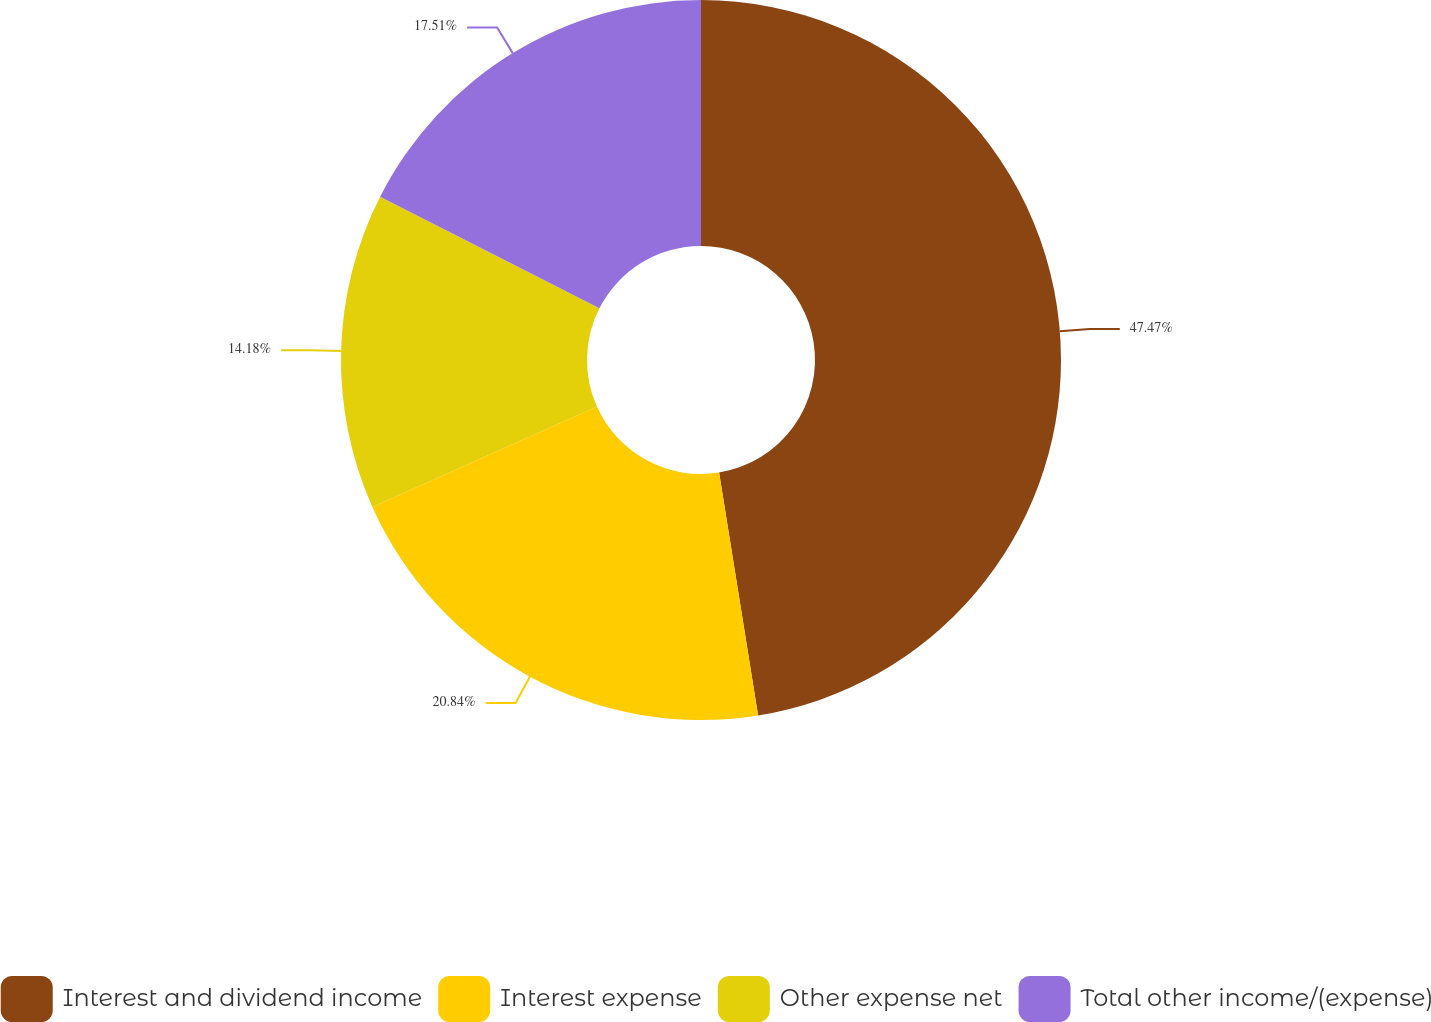Convert chart. <chart><loc_0><loc_0><loc_500><loc_500><pie_chart><fcel>Interest and dividend income<fcel>Interest expense<fcel>Other expense net<fcel>Total other income/(expense)<nl><fcel>47.46%<fcel>20.84%<fcel>14.18%<fcel>17.51%<nl></chart> 